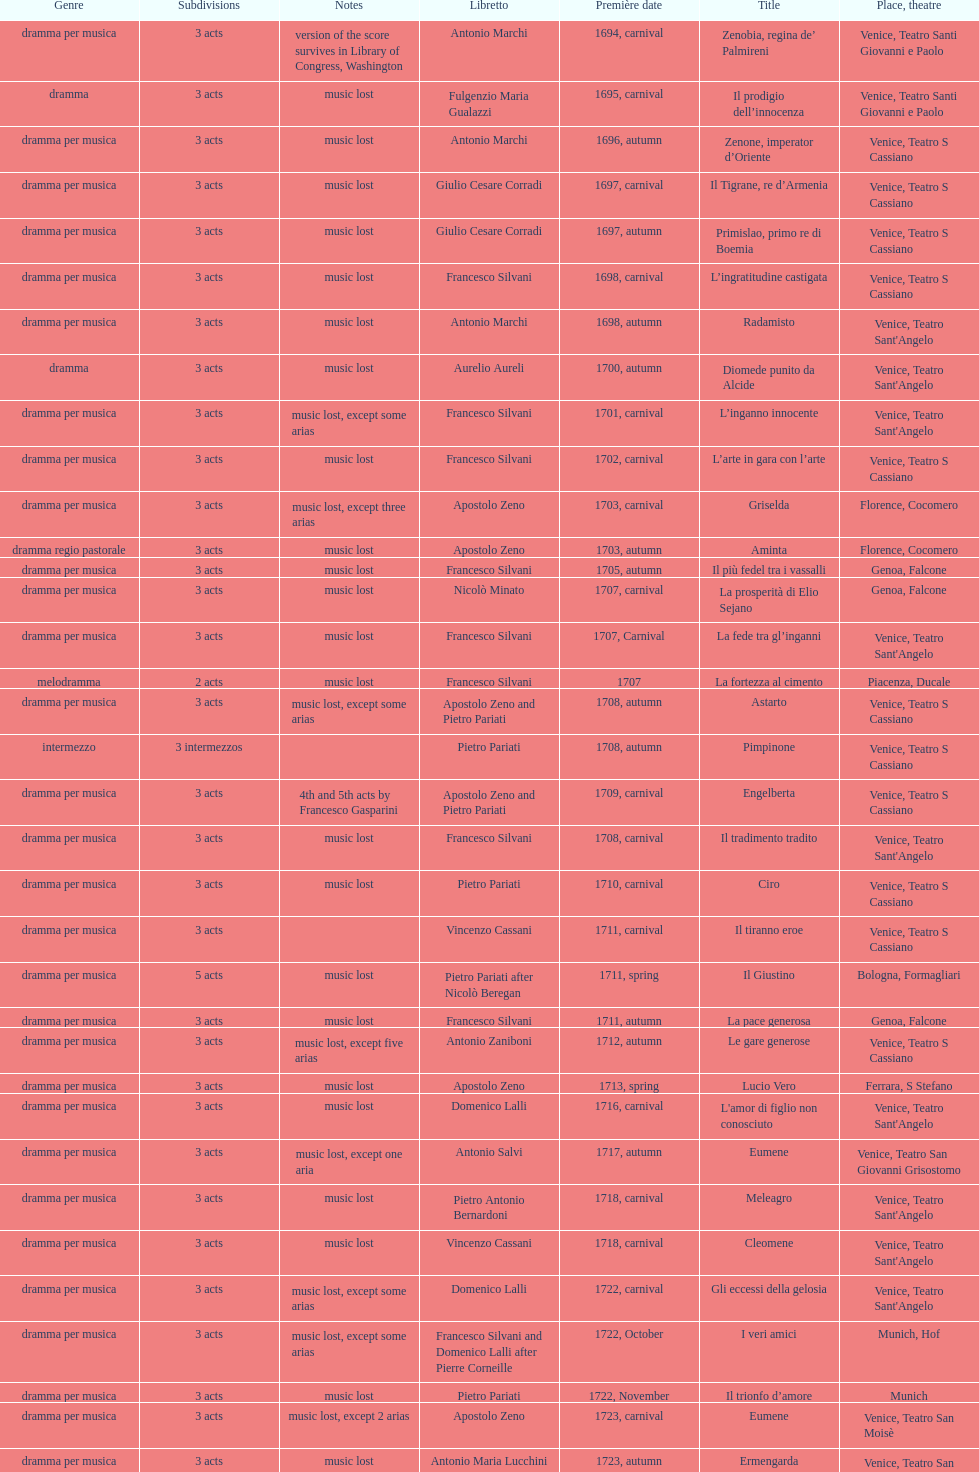Which opera has at least 5 acts? Il Giustino. 